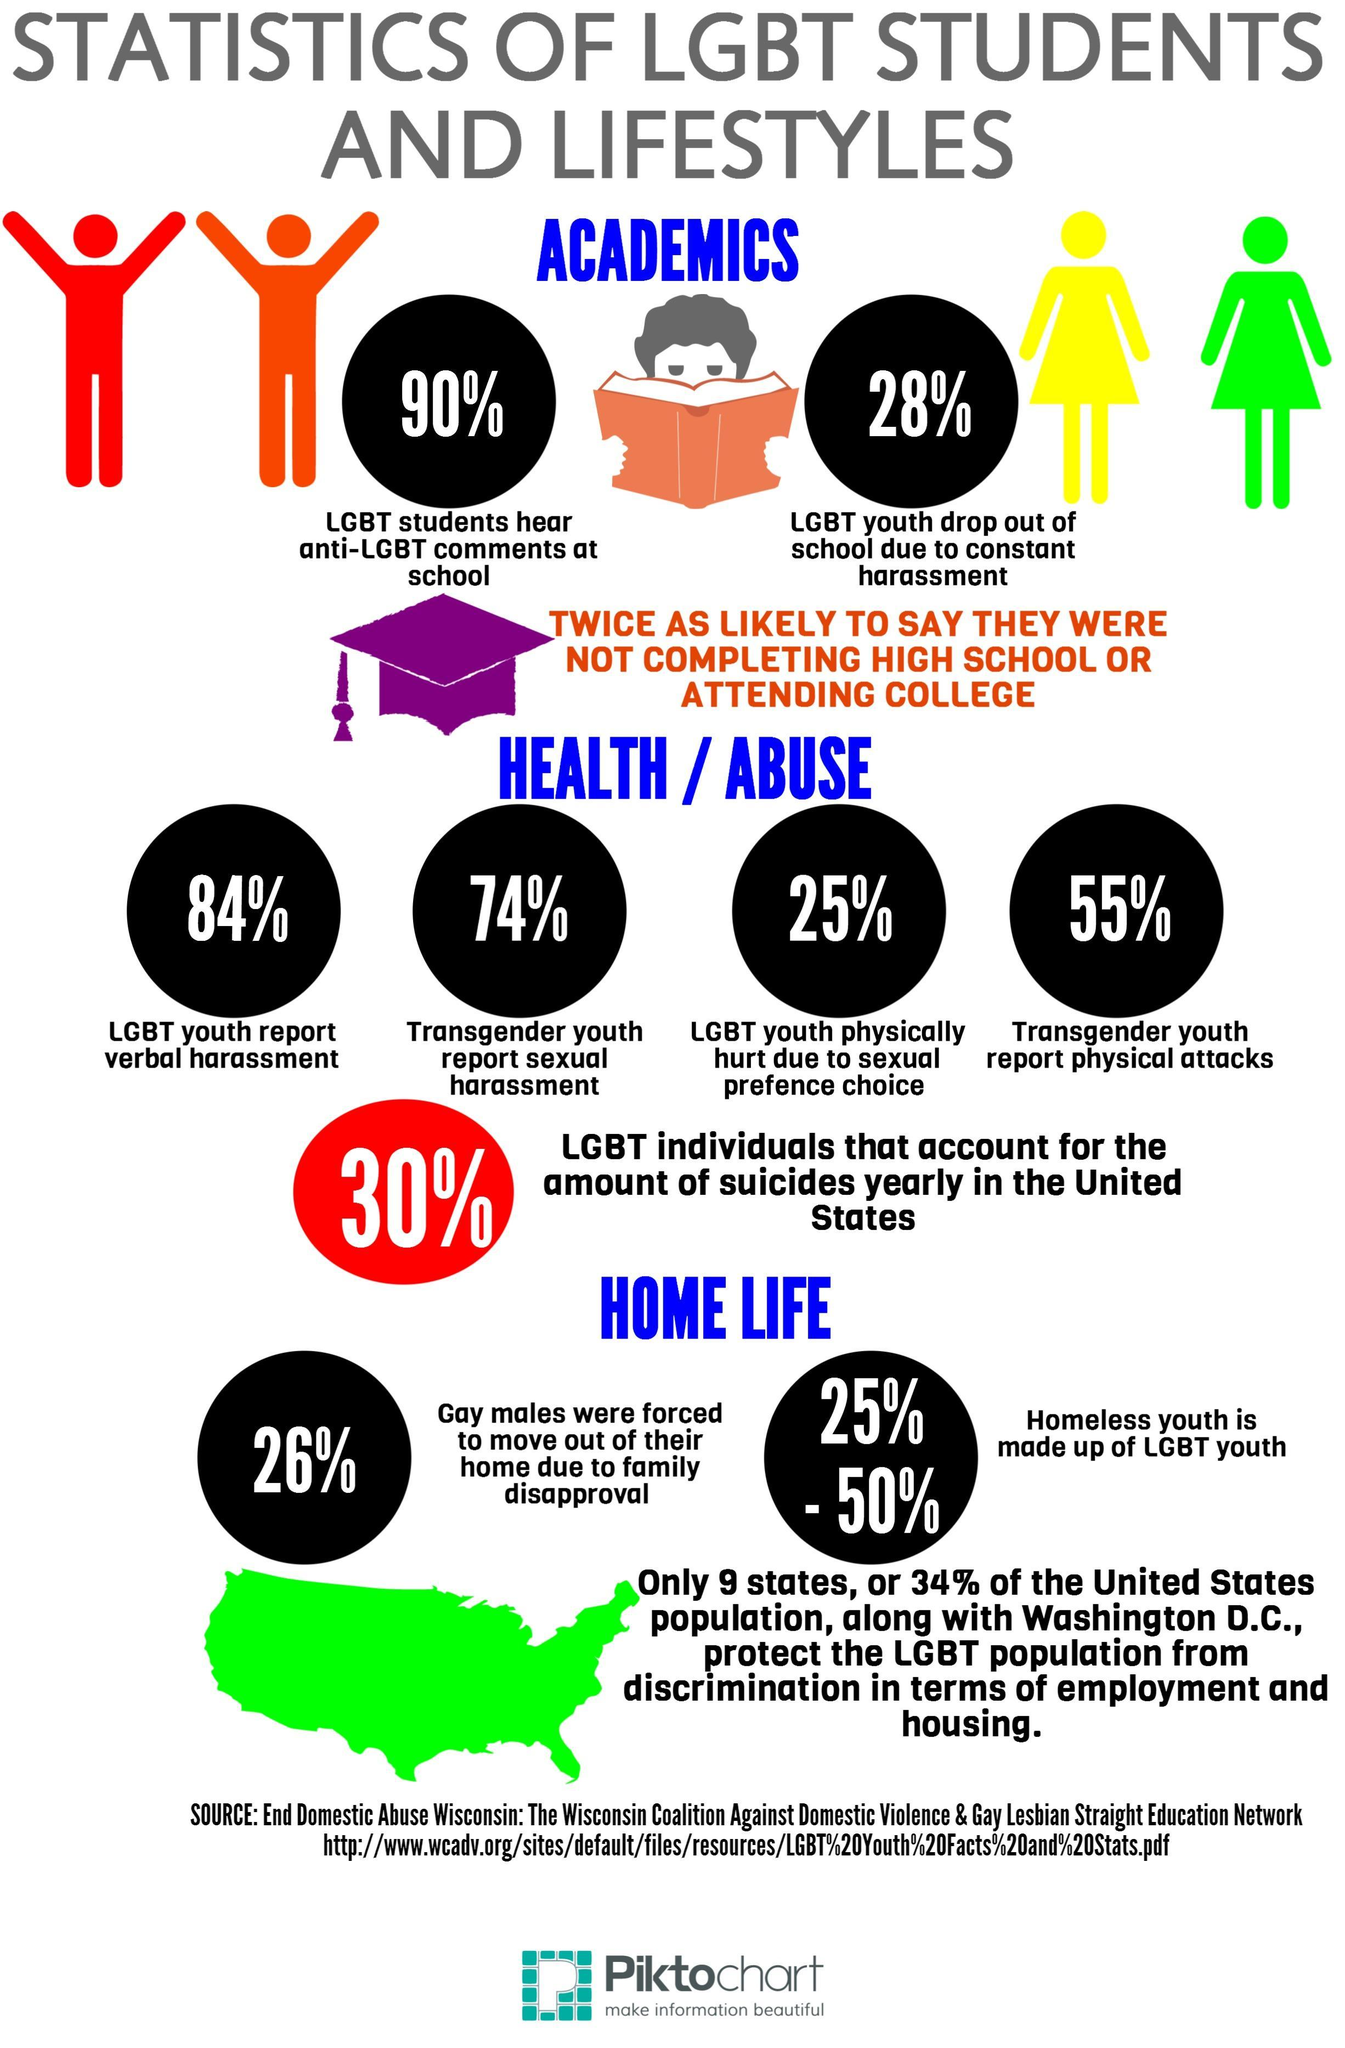What is the total percentage of LGBT community that report abuse?
Answer the question with a short phrase. 238% How many states do not offer protection to LGBT population? 41 What percentage of LGBT students do not hear anti-LGBT comments at school ? 10% 